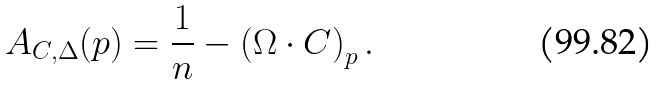<formula> <loc_0><loc_0><loc_500><loc_500>A _ { C , \Delta } ( p ) = \frac { 1 } { n } - \left ( \Omega \cdot C \right ) _ { p } .</formula> 